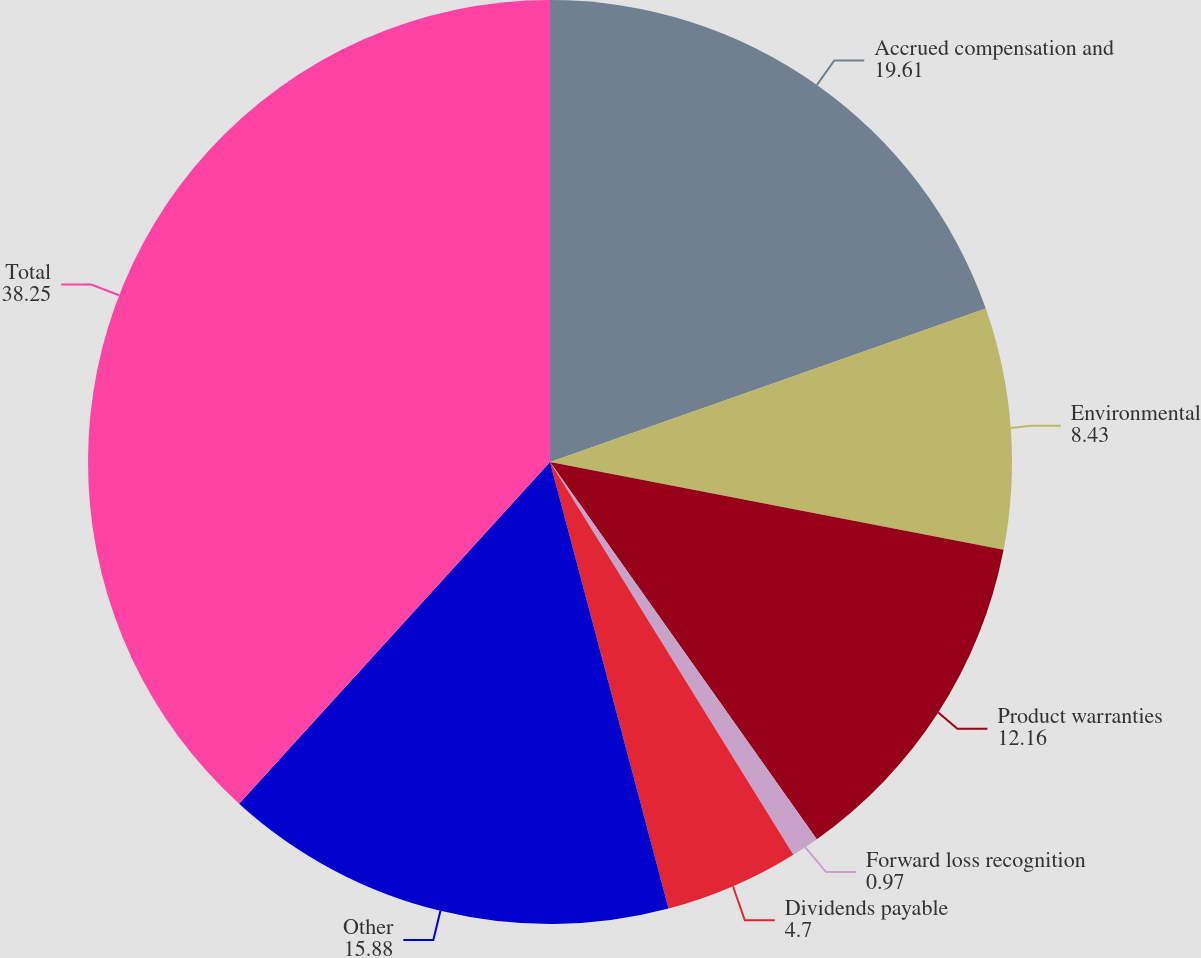<chart> <loc_0><loc_0><loc_500><loc_500><pie_chart><fcel>Accrued compensation and<fcel>Environmental<fcel>Product warranties<fcel>Forward loss recognition<fcel>Dividends payable<fcel>Other<fcel>Total<nl><fcel>19.61%<fcel>8.43%<fcel>12.16%<fcel>0.97%<fcel>4.7%<fcel>15.88%<fcel>38.25%<nl></chart> 